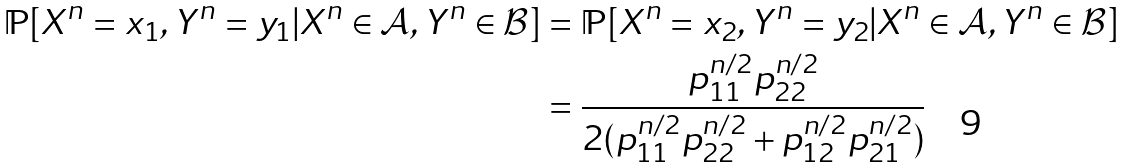<formula> <loc_0><loc_0><loc_500><loc_500>\mathbb { P } [ X ^ { n } = x _ { 1 } , Y ^ { n } = y _ { 1 } | X ^ { n } \in \mathcal { A } , Y ^ { n } \in \mathcal { B } ] & = \mathbb { P } [ X ^ { n } = x _ { 2 } , Y ^ { n } = y _ { 2 } | X ^ { n } \in \mathcal { A } , Y ^ { n } \in \mathcal { B } ] \\ & = \frac { p _ { 1 1 } ^ { n / 2 } p _ { 2 2 } ^ { n / 2 } } { 2 ( p _ { 1 1 } ^ { n / 2 } p _ { 2 2 } ^ { n / 2 } + p _ { 1 2 } ^ { n / 2 } p _ { 2 1 } ^ { n / 2 } ) }</formula> 